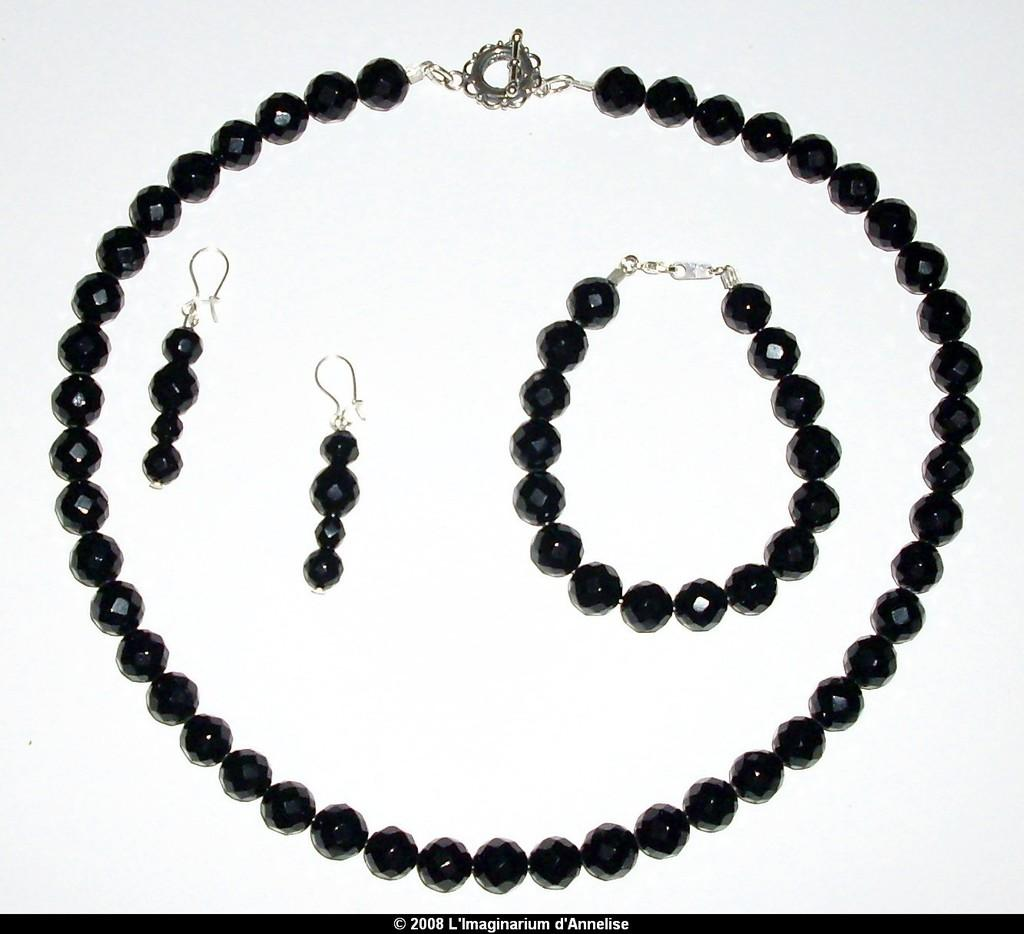What is the main subject in the center of the image? There is a necklace, a bracelet, and earrings in the center of the image. What color are the necklace, bracelet, and earrings? They are all black in color. Is there any text present in the image? Yes, there is some text at the bottom of the image. How does the necklace exchange breath with the bracelet in the image? There is no exchange of breath between the necklace and the bracelet in the image, as they are inanimate objects. 